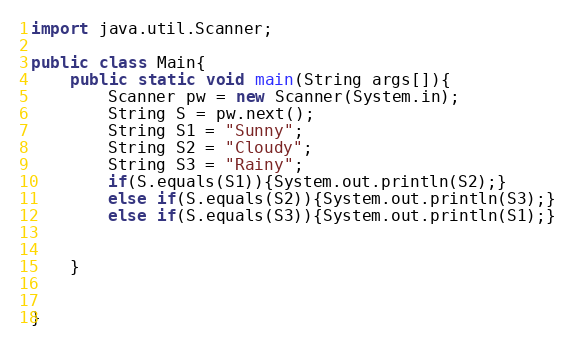Convert code to text. <code><loc_0><loc_0><loc_500><loc_500><_Java_>import java.util.Scanner;

public class Main{
	public static void main(String args[]){
		Scanner pw = new Scanner(System.in);
		String S = pw.next();
		String S1 = "Sunny";
		String S2 = "Cloudy";
		String S3 = "Rainy";
		if(S.equals(S1)){System.out.println(S2);}
		else if(S.equals(S2)){System.out.println(S3);}
		else if(S.equals(S3)){System.out.println(S1);}
		
		
	}
	

}</code> 